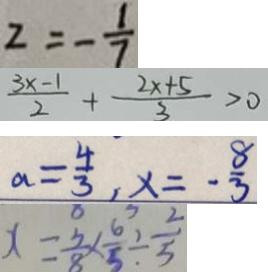<formula> <loc_0><loc_0><loc_500><loc_500>z = - \frac { 1 } { 7 } 
 \frac { 2 x + 5 } { 2 } + \frac { 2 x - 1 } { 3 } > 0 
 a = \frac { 4 } { 3 } , x = - \frac { 8 } { 3 } 
 x = \frac { 5 } { 8 } \times \frac { 6 } { 5 } \div \frac { 2 } { 5 }</formula> 